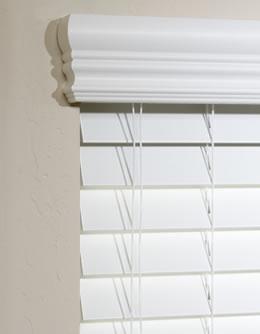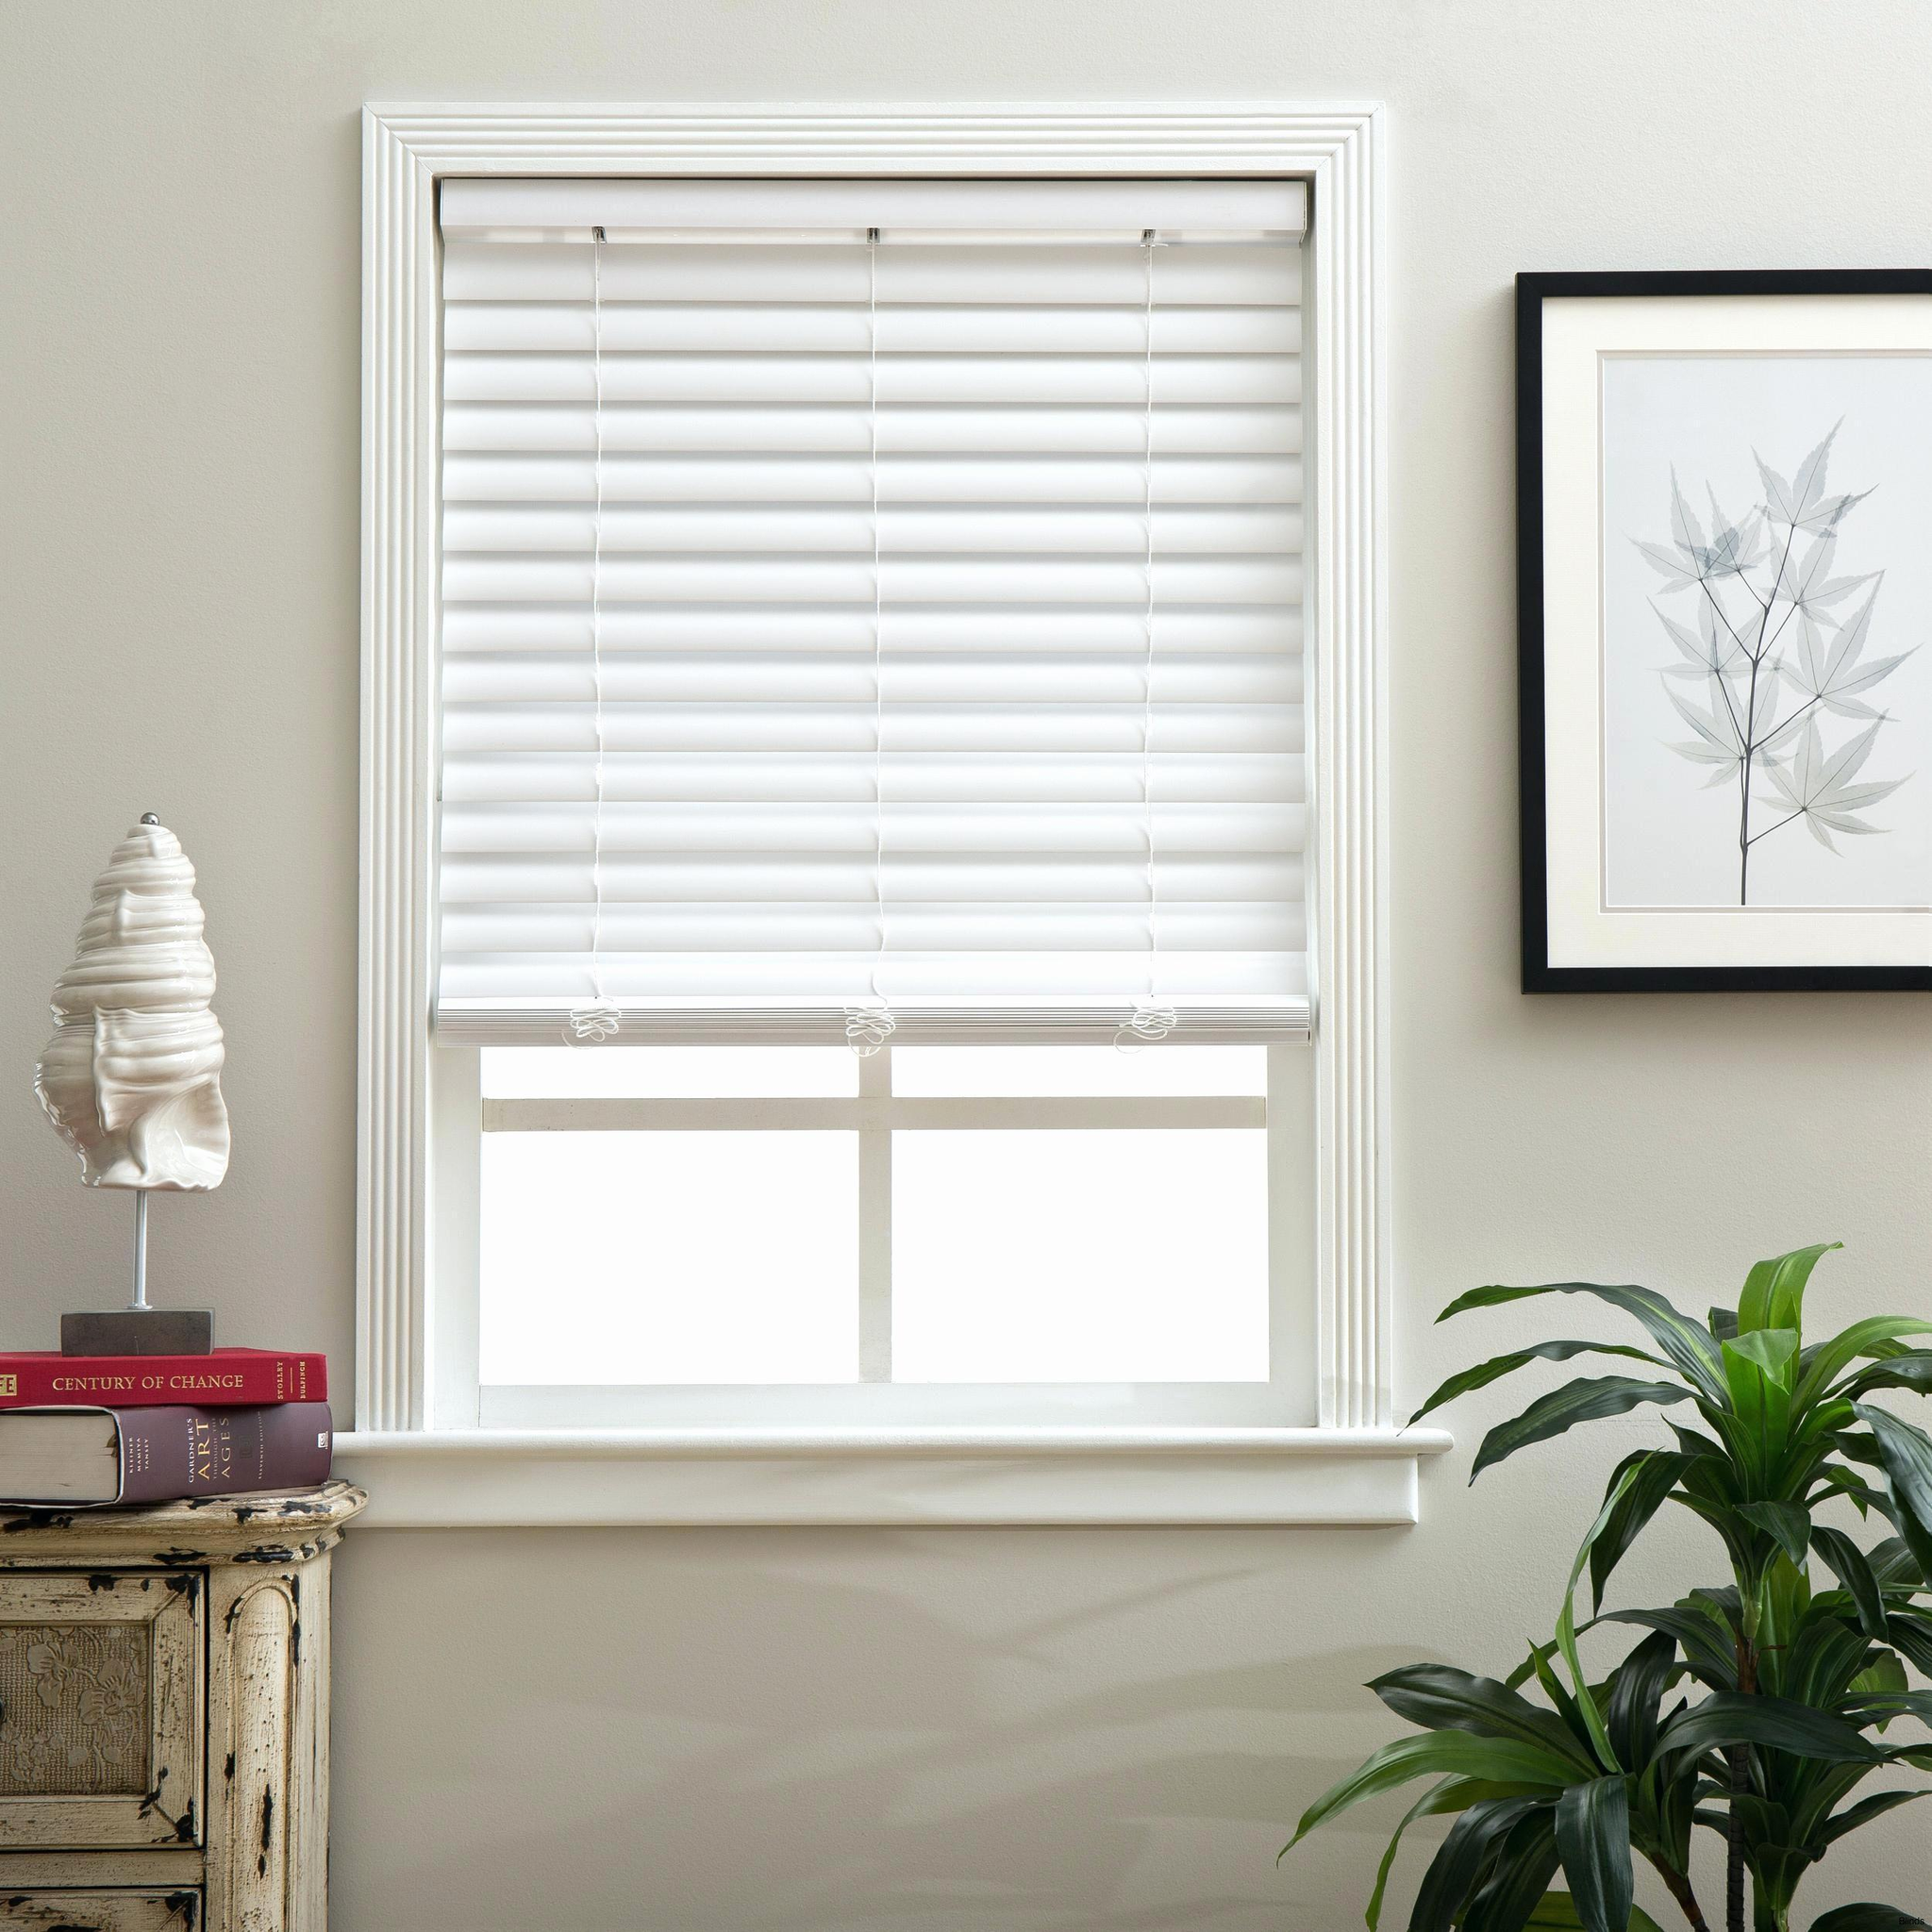The first image is the image on the left, the second image is the image on the right. Considering the images on both sides, is "At least two shades are partially pulled up." valid? Answer yes or no. No. The first image is the image on the left, the second image is the image on the right. Analyze the images presented: Is the assertion "There are a total of four blinds." valid? Answer yes or no. No. 